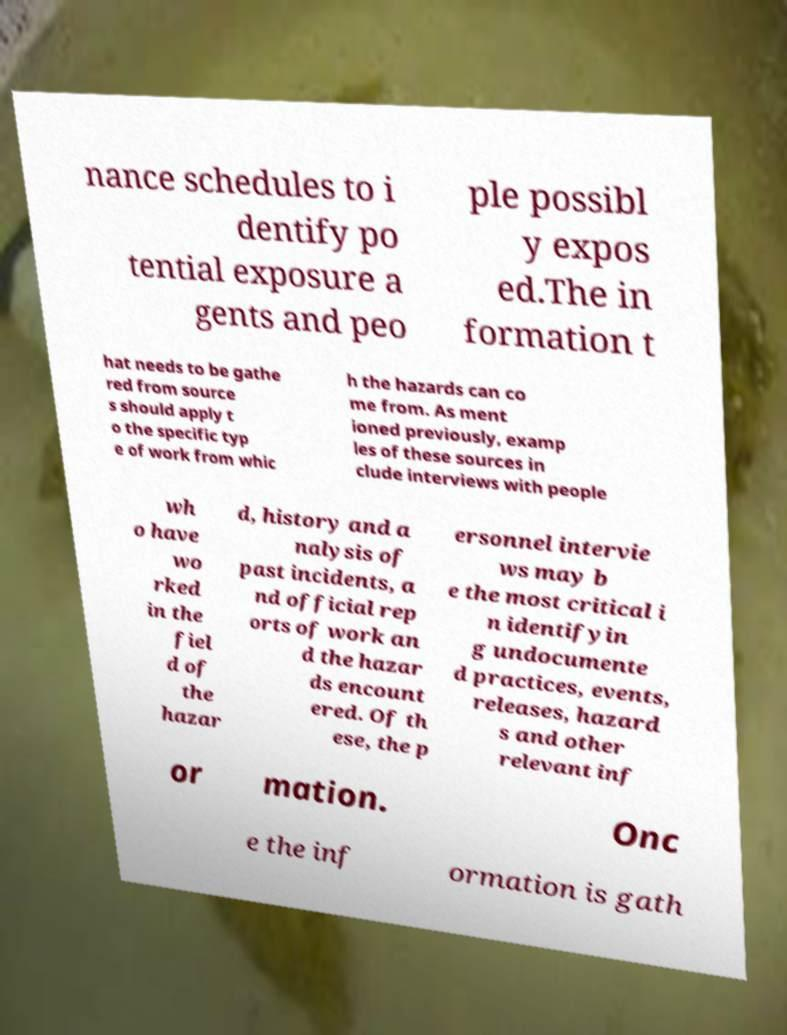Can you accurately transcribe the text from the provided image for me? nance schedules to i dentify po tential exposure a gents and peo ple possibl y expos ed.The in formation t hat needs to be gathe red from source s should apply t o the specific typ e of work from whic h the hazards can co me from. As ment ioned previously, examp les of these sources in clude interviews with people wh o have wo rked in the fiel d of the hazar d, history and a nalysis of past incidents, a nd official rep orts of work an d the hazar ds encount ered. Of th ese, the p ersonnel intervie ws may b e the most critical i n identifyin g undocumente d practices, events, releases, hazard s and other relevant inf or mation. Onc e the inf ormation is gath 